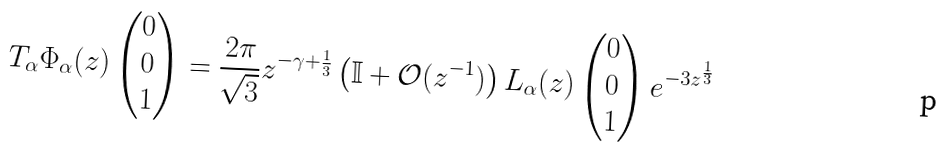<formula> <loc_0><loc_0><loc_500><loc_500>T _ { \alpha } \Phi _ { \alpha } ( z ) \begin{pmatrix} 0 \\ 0 \\ 1 \end{pmatrix} = \frac { 2 \pi } { \sqrt { 3 } } z ^ { - \gamma + \frac { 1 } { 3 } } \left ( \mathbb { I } + \mathcal { O } ( z ^ { - 1 } ) \right ) L _ { \alpha } ( z ) \begin{pmatrix} 0 \\ 0 \\ 1 \end{pmatrix} e ^ { - 3 z ^ { \frac { 1 } { 3 } } }</formula> 